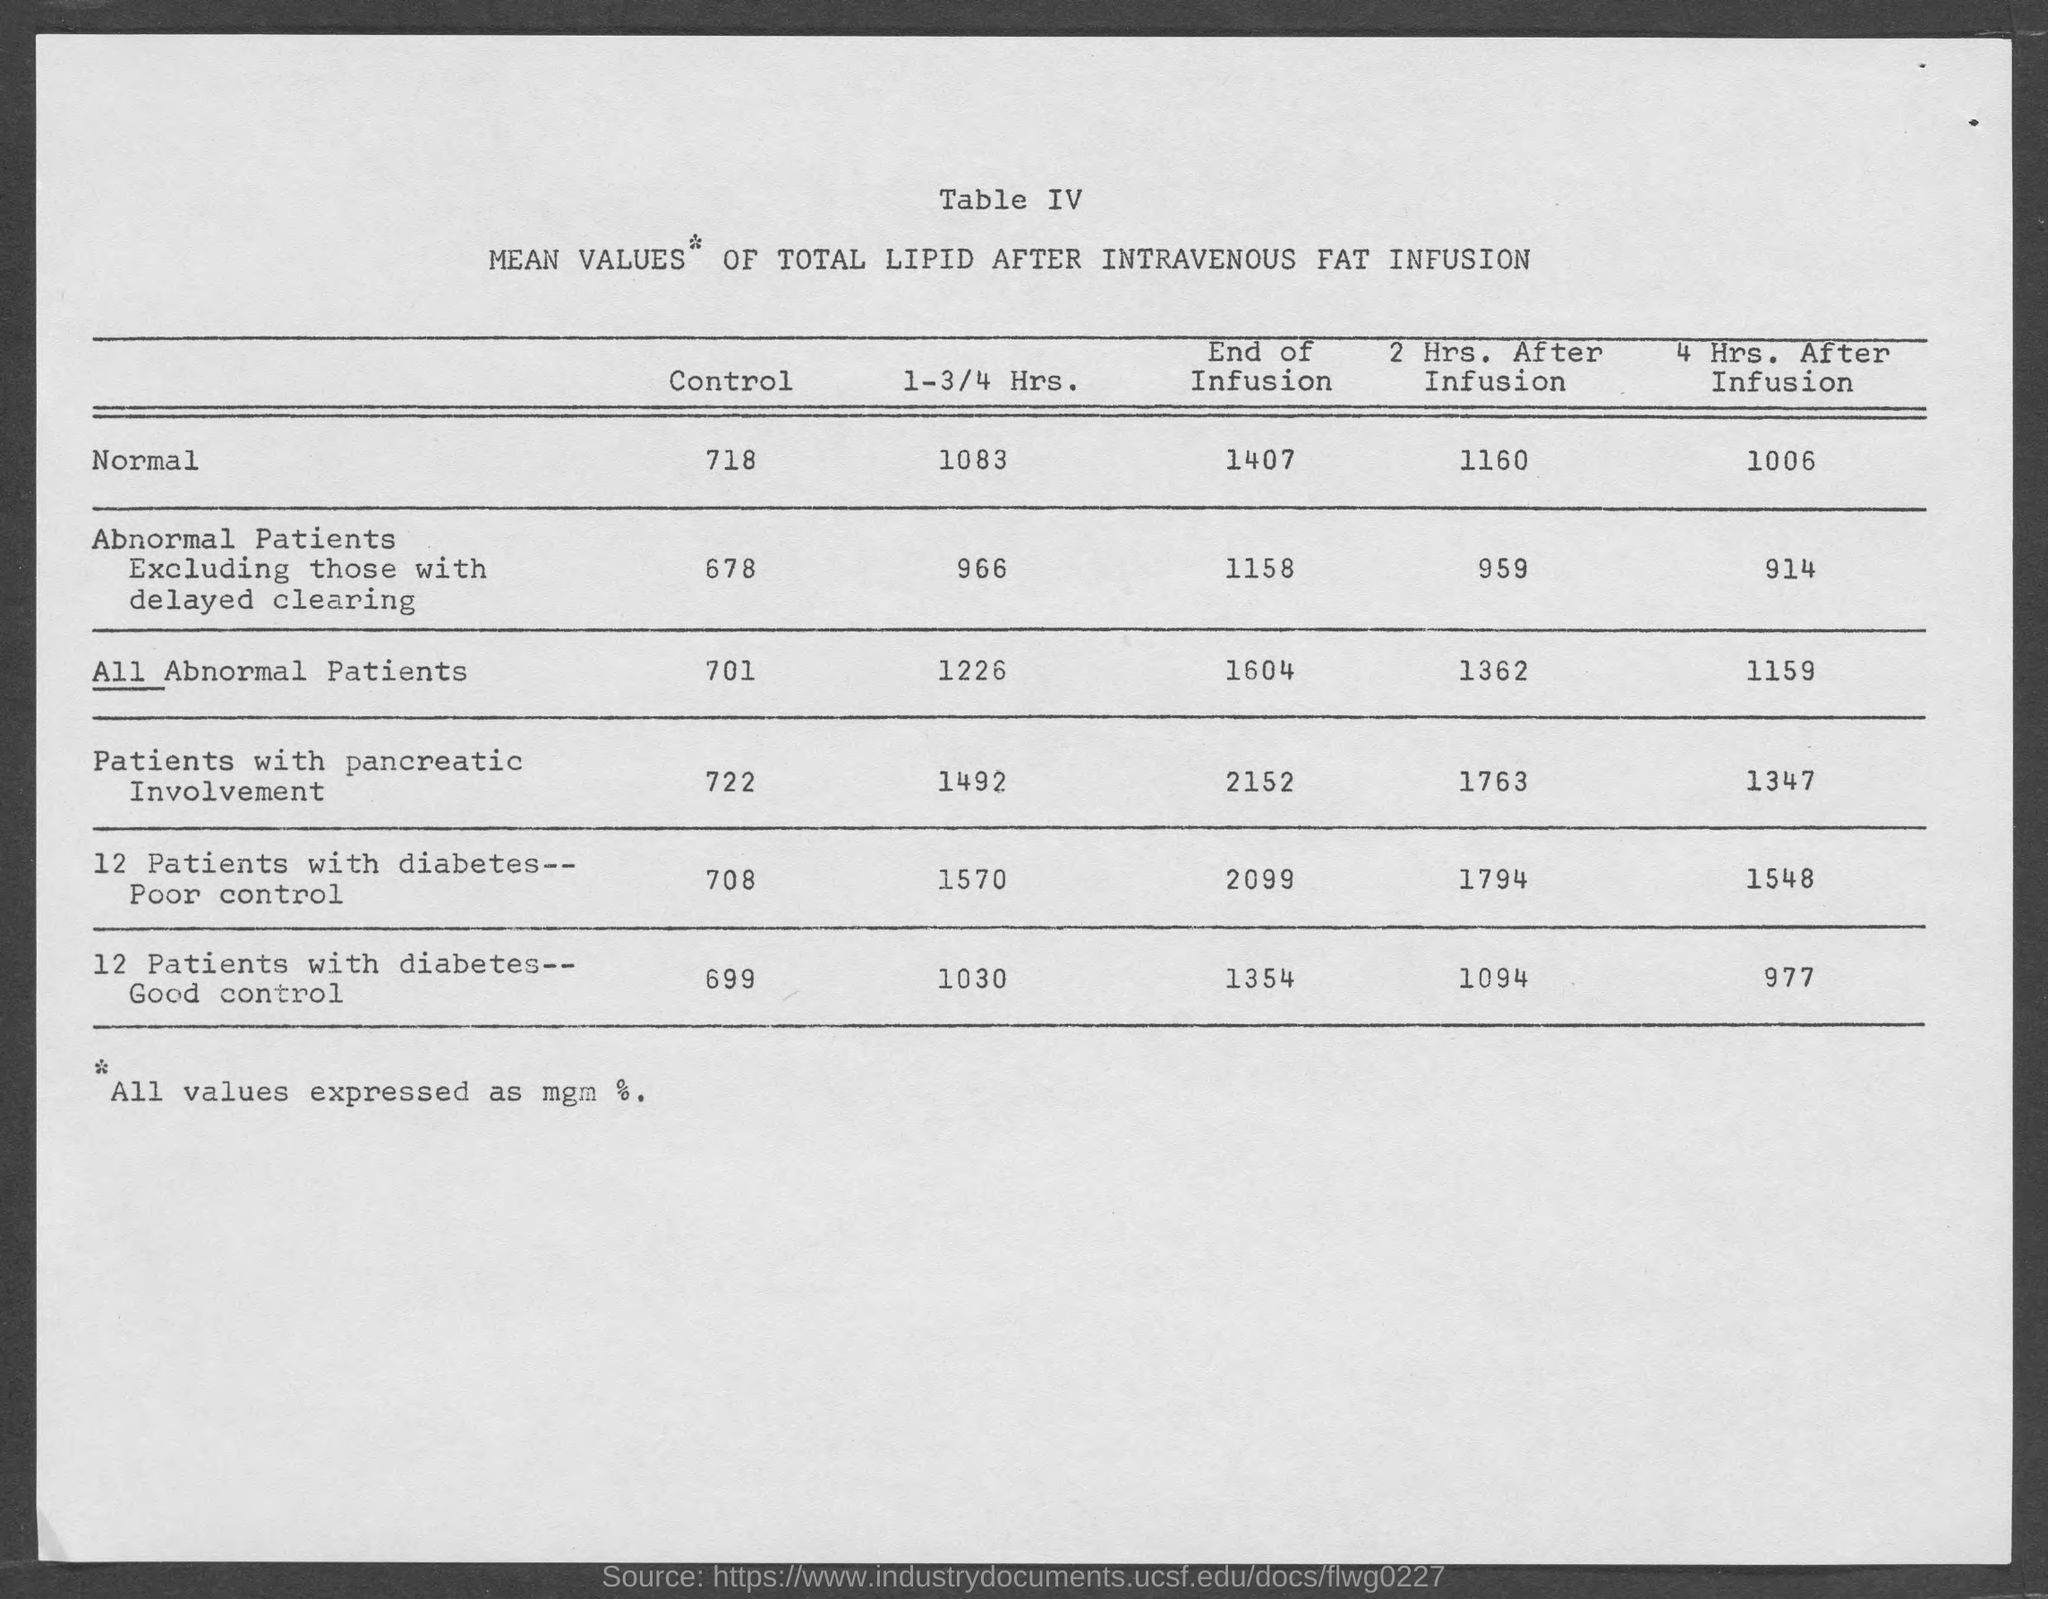List a handful of essential elements in this visual. The normal control is 718. 